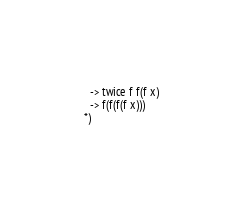Convert code to text. <code><loc_0><loc_0><loc_500><loc_500><_OCaml_>  -> twice f f(f x)
  -> f(f(f(f x)))
*)
</code> 